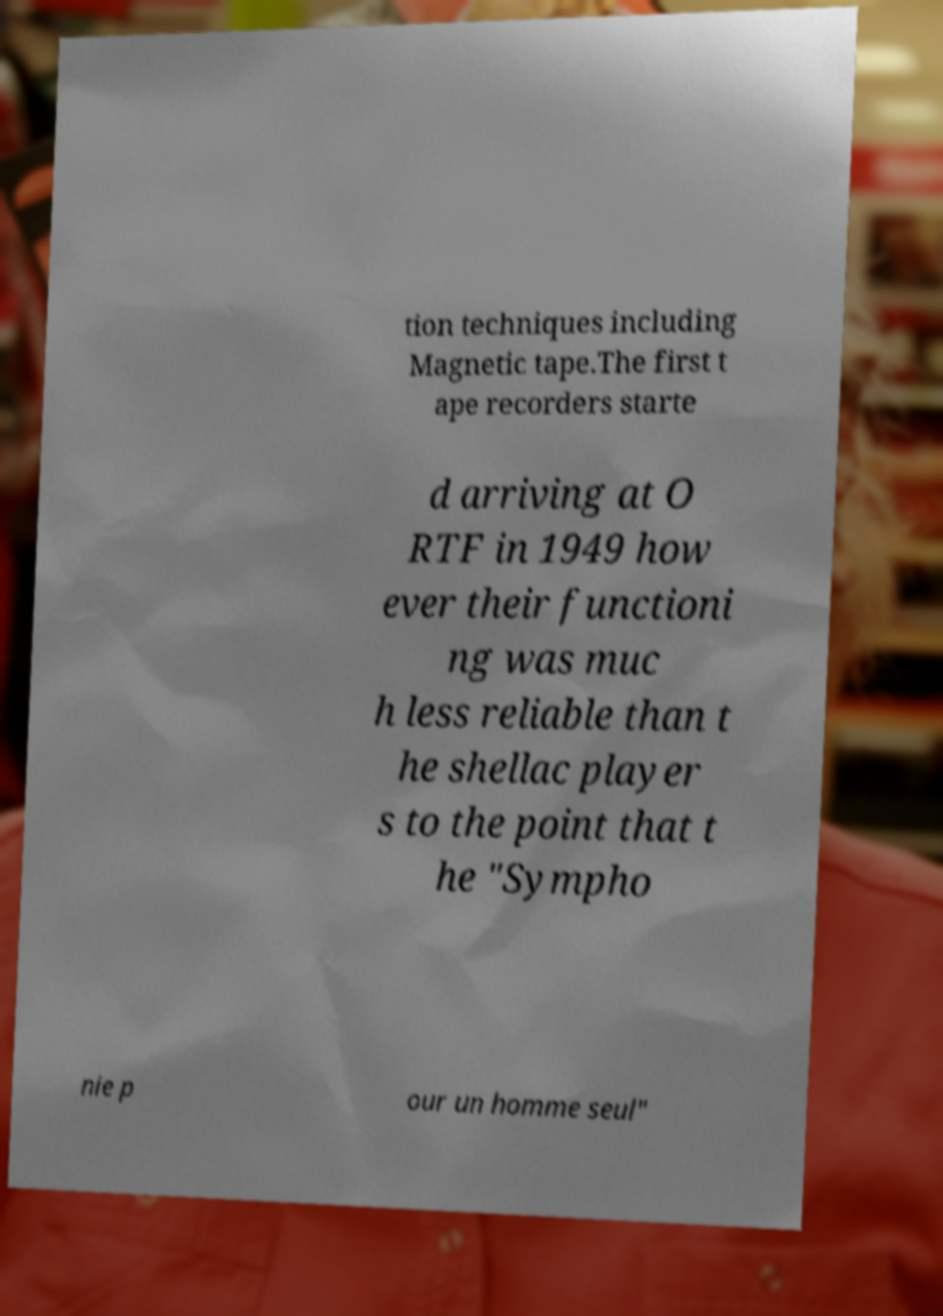Can you accurately transcribe the text from the provided image for me? tion techniques including Magnetic tape.The first t ape recorders starte d arriving at O RTF in 1949 how ever their functioni ng was muc h less reliable than t he shellac player s to the point that t he "Sympho nie p our un homme seul" 